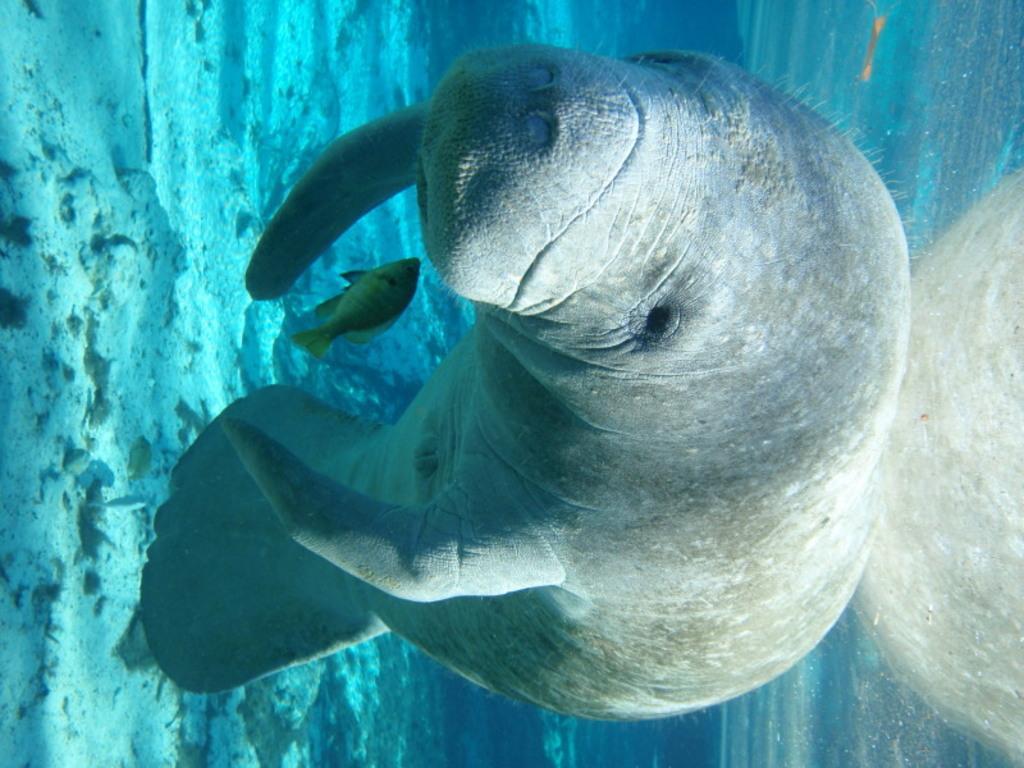In one or two sentences, can you explain what this image depicts? In this image, we can see a seal and a fish. We can see some water and the ground with some objects. We can also see some object on the right. 